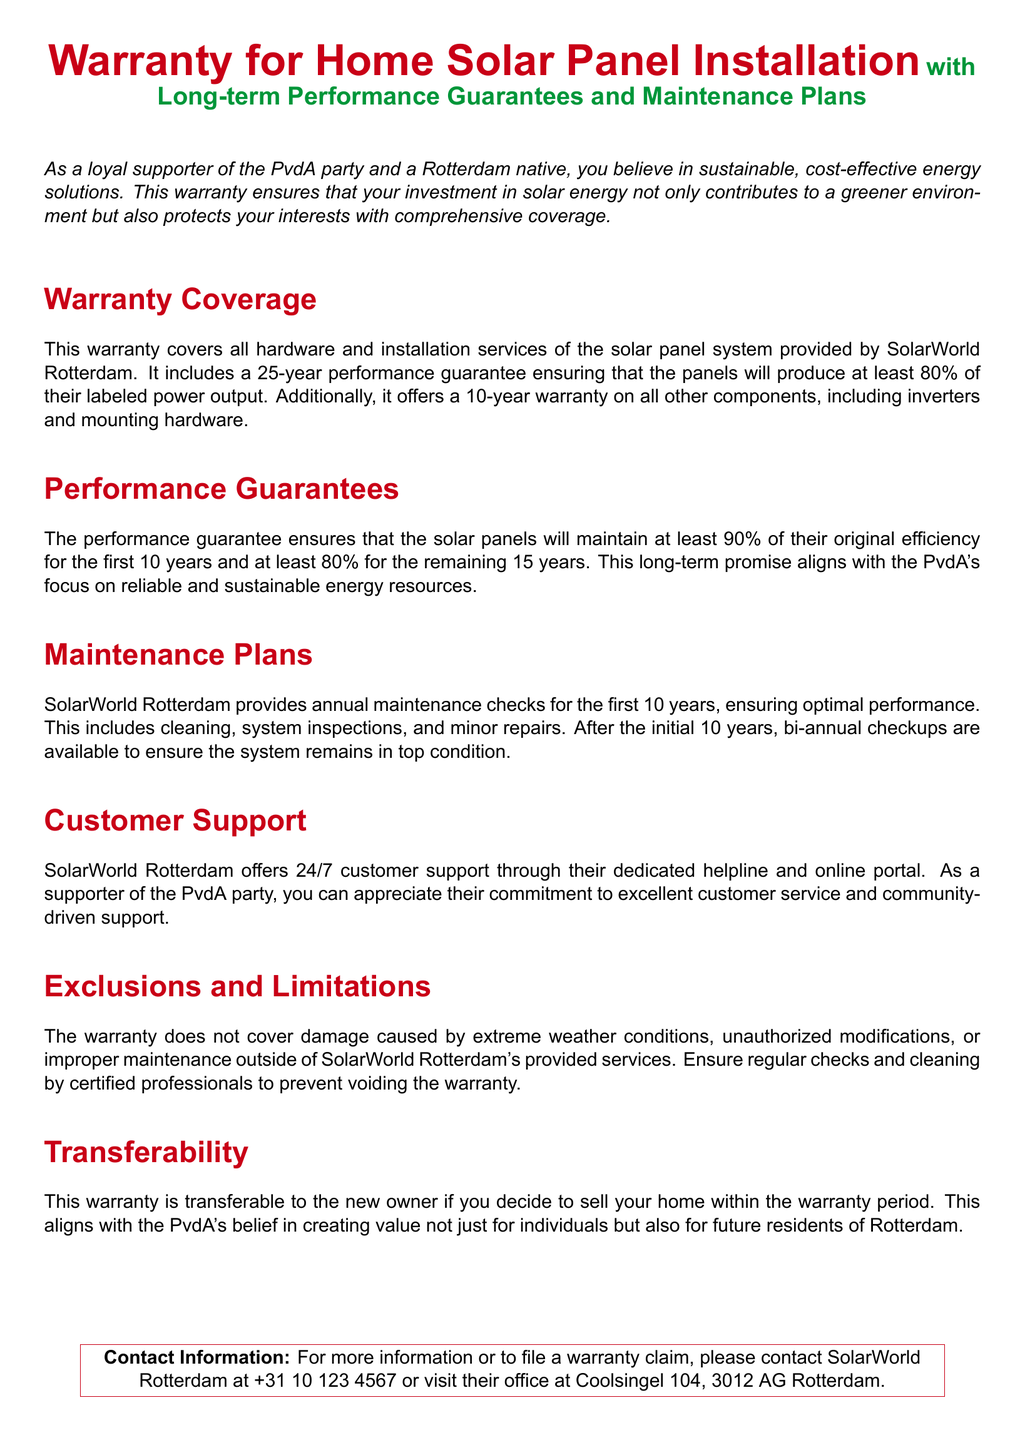What is the performance guarantee duration for the solar panels? The performance guarantee for the solar panels is 25 years, with specific efficiency levels for the first 10 years and the remaining 15 years.
Answer: 25 years What percentage of efficiency must the solar panels maintain after 10 years? The document states the solar panels must maintain at least 90% efficiency for the first 10 years.
Answer: 90% What is the warranty on inverters and mounting hardware? The warranty on inverters and mounting hardware is included in the 10-year component warranty provided.
Answer: 10 years How often are maintenance checks provided in the first 10 years? SolarWorld Rotterdam provides annual maintenance checks for the first 10 years.
Answer: Annual What happens to the warranty if the home is sold? The warranty is transferable to the new owner if you decide to sell your home within the warranty period.
Answer: Transferable What is not covered by the warranty? The warranty does not cover damage caused by extreme weather conditions, unauthorized modifications, or improper maintenance.
Answer: Extreme weather How can customers contact SolarWorld Rotterdam for support? Customers can contact SolarWorld Rotterdam through their dedicated helpline and online portal, which are available 24/7.
Answer: 24/7 customer support What is the phone number for SolarWorld Rotterdam? The document provides a specific contact number for warranty claims and information.
Answer: +31 10 123 4567 